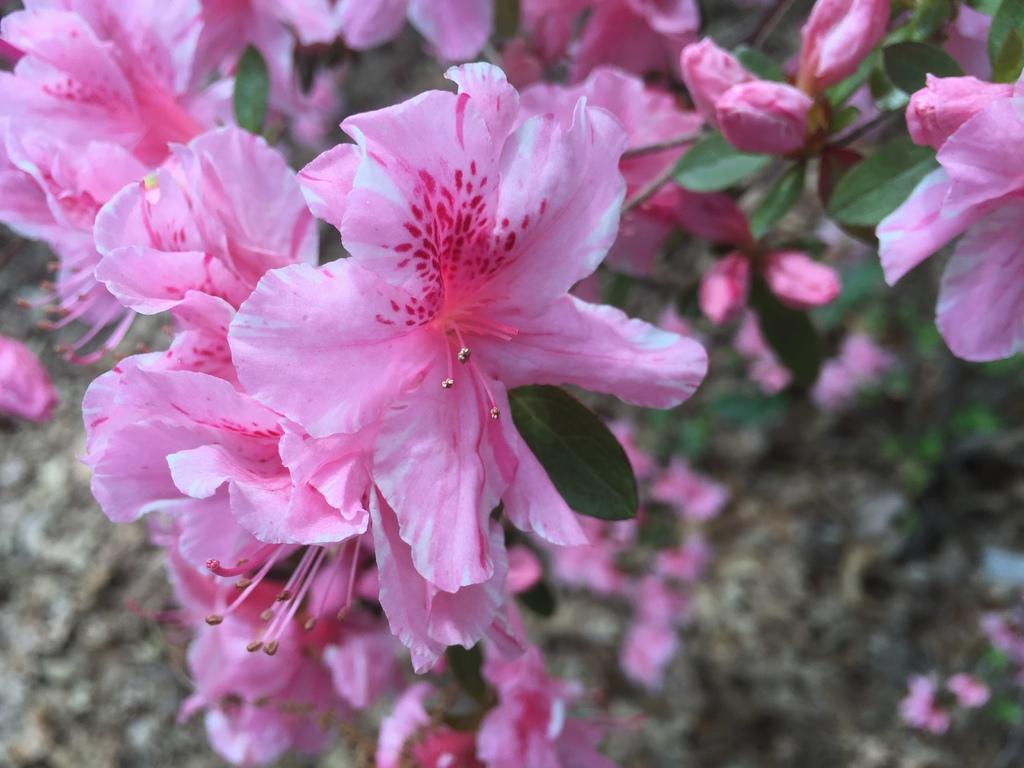In one or two sentences, can you explain what this image depicts? The picture consists of flowers, leaves and stems. The background is blurred. 